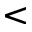<formula> <loc_0><loc_0><loc_500><loc_500><</formula> 